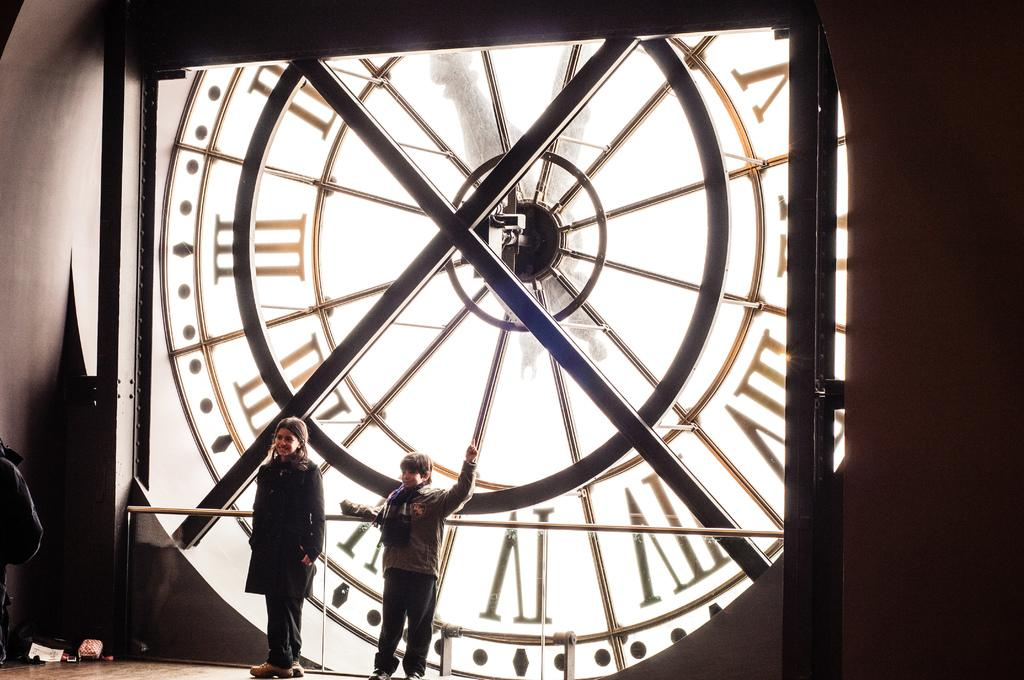How many children are present in the image? There are two kids in the image. What are the kids standing in front of? The kids are standing in front of a huge clock. What type of fuel is used to power the clock in the image? There is no information about the clock's power source in the image, and therefore no such detail can be determined. 